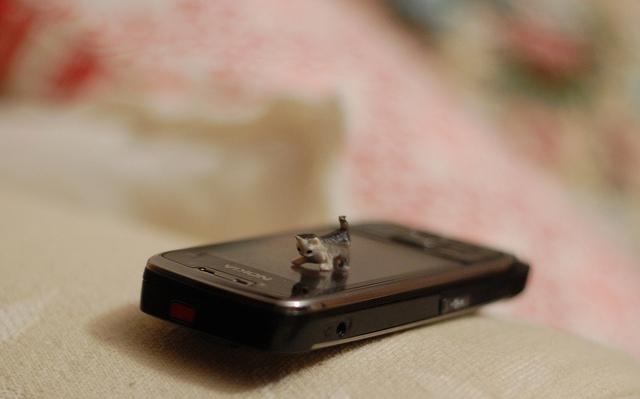Based on the phone size about what size is the cat sculpture? tiny 